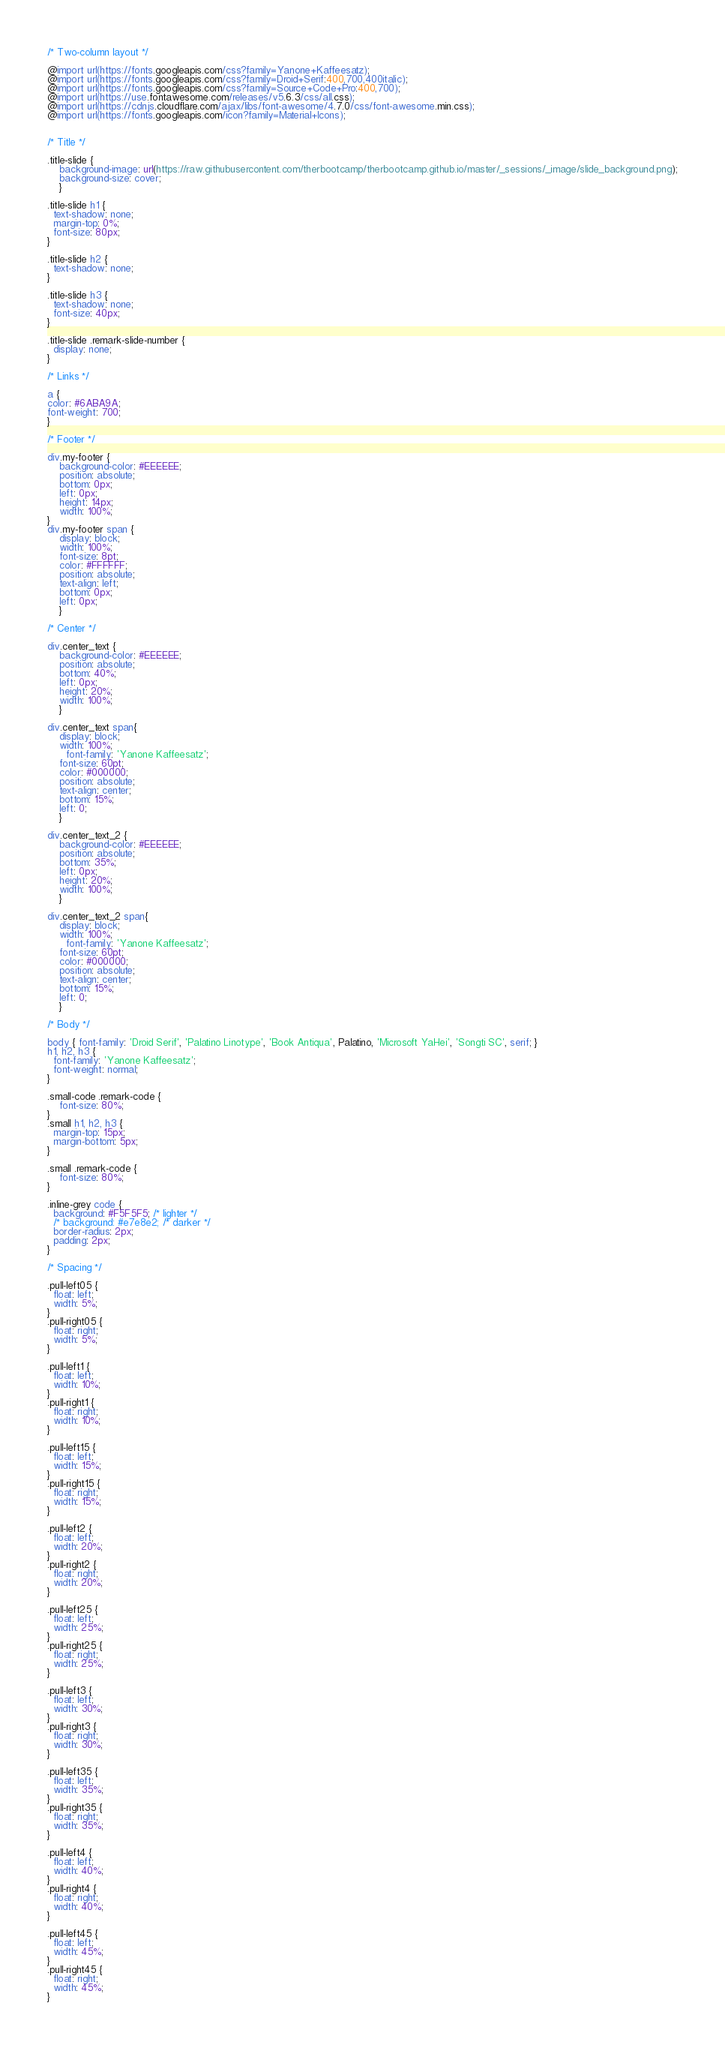Convert code to text. <code><loc_0><loc_0><loc_500><loc_500><_CSS_>/* Two-column layout */

@import url(https://fonts.googleapis.com/css?family=Yanone+Kaffeesatz);
@import url(https://fonts.googleapis.com/css?family=Droid+Serif:400,700,400italic);
@import url(https://fonts.googleapis.com/css?family=Source+Code+Pro:400,700);
@import url(https://use.fontawesome.com/releases/v5.6.3/css/all.css);
@import url(https://cdnjs.cloudflare.com/ajax/libs/font-awesome/4.7.0/css/font-awesome.min.css);
@import url(https://fonts.googleapis.com/icon?family=Material+Icons);


/* Title */

.title-slide {
	background-image: url(https://raw.githubusercontent.com/therbootcamp/therbootcamp.github.io/master/_sessions/_image/slide_background.png);
	background-size: cover;
	}

.title-slide h1 {
  text-shadow: none;
  margin-top: 0%;
  font-size: 80px;
}

.title-slide h2 {
  text-shadow: none;
}

.title-slide h3 {
  text-shadow: none;
  font-size: 40px;
}

.title-slide .remark-slide-number {
  display: none;
}

/* Links */

a {
color: #6ABA9A;
font-weight: 700;
}

/* Footer */

div.my-footer {
    background-color: #EEEEEE;
    position: absolute;
    bottom: 0px;
    left: 0px;
    height: 14px;
    width: 100%;
}
div.my-footer span {
	display: block;
	width: 100%;
    font-size: 8pt;
    color: #FFFFFF;
    position: absolute;
    text-align: left;
    bottom: 0px;
    left: 0px;
	}

/* Center */

div.center_text {
    background-color: #EEEEEE;
    position: absolute;
    bottom: 40%;
    left: 0px;
    height: 20%;
    width: 100%;
	}

div.center_text span{
	display: block;
	width: 100%;
	  font-family: 'Yanone Kaffeesatz';
    font-size: 60pt;
    color: #000000;
    position: absolute;
    text-align: center;
    bottom: 15%;
    left: 0;
	}

div.center_text_2 {
    background-color: #EEEEEE;
    position: absolute;
    bottom: 35%;
    left: 0px;
    height: 20%;
    width: 100%;
	}

div.center_text_2 span{
	display: block;
	width: 100%;
	  font-family: 'Yanone Kaffeesatz';
    font-size: 60pt;
    color: #000000;
    position: absolute;
    text-align: center;
    bottom: 15%;
    left: 0;
	}

/* Body */

body { font-family: 'Droid Serif', 'Palatino Linotype', 'Book Antiqua', Palatino, 'Microsoft YaHei', 'Songti SC', serif; }
h1, h2, h3 {
  font-family: 'Yanone Kaffeesatz';
  font-weight: normal;
}

.small-code .remark-code {
    font-size: 80%;
}
.small h1, h2, h3 {
  margin-top: 15px;
  margin-bottom: 5px;
}

.small .remark-code {
    font-size: 80%;
}

.inline-grey code {
  background: #F5F5F5; /* lighter */
  /* background: #e7e8e2; /* darker */
  border-radius: 2px;
  padding: 2px;
}

/* Spacing */

.pull-left05 {
  float: left;
  width: 5%;
}
.pull-right05 {
  float: right;
  width: 5%;
}

.pull-left1 {
  float: left;
  width: 10%;
}
.pull-right1 {
  float: right;
  width: 10%;
}

.pull-left15 {
  float: left;
  width: 15%;
}
.pull-right15 {
  float: right;
  width: 15%;
}

.pull-left2 {
  float: left;
  width: 20%;
}
.pull-right2 {
  float: right;
  width: 20%;
}

.pull-left25 {
  float: left;
  width: 25%;
}
.pull-right25 {
  float: right;
  width: 25%;
}

.pull-left3 {
  float: left;
  width: 30%;
}
.pull-right3 {
  float: right;
  width: 30%;
}

.pull-left35 {
  float: left;
  width: 35%;
}
.pull-right35 {
  float: right;
  width: 35%;
}

.pull-left4 {
  float: left;
  width: 40%;
}
.pull-right4 {
  float: right;
  width: 40%;
}

.pull-left45 {
  float: left;
  width: 45%;
}
.pull-right45 {
  float: right;
  width: 45%;
}
</code> 